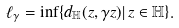Convert formula to latex. <formula><loc_0><loc_0><loc_500><loc_500>\ell _ { \gamma } = \inf \{ { d _ { \mathbb { H } } ( z , \gamma z ) | \, z \in \mathbb { H } \} } .</formula> 